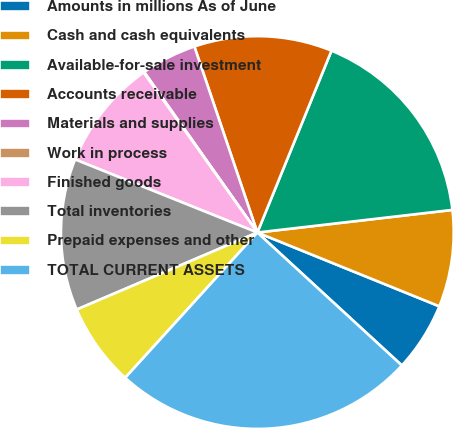Convert chart. <chart><loc_0><loc_0><loc_500><loc_500><pie_chart><fcel>Amounts in millions As of June<fcel>Cash and cash equivalents<fcel>Available-for-sale investment<fcel>Accounts receivable<fcel>Materials and supplies<fcel>Work in process<fcel>Finished goods<fcel>Total inventories<fcel>Prepaid expenses and other<fcel>TOTAL CURRENT ASSETS<nl><fcel>5.71%<fcel>7.97%<fcel>17.01%<fcel>11.36%<fcel>4.58%<fcel>0.06%<fcel>9.1%<fcel>12.49%<fcel>6.84%<fcel>24.92%<nl></chart> 